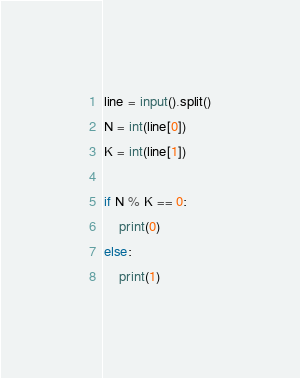Convert code to text. <code><loc_0><loc_0><loc_500><loc_500><_Python_>line = input().split()
N = int(line[0])
K = int(line[1])

if N % K == 0:
    print(0)
else:
    print(1)
</code> 